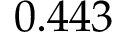Convert formula to latex. <formula><loc_0><loc_0><loc_500><loc_500>0 . 4 4 3</formula> 